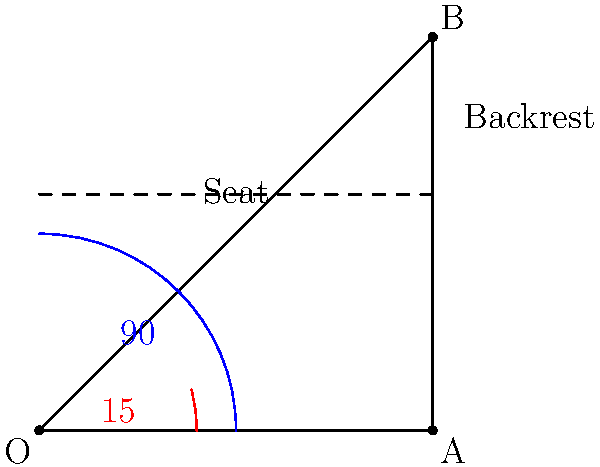As a chess historian, you're researching the optimal seating arrangements for players during famous matches. What is the recommended angle between the seat and backrest of a chess player's chair based on ergonomic principles? To determine the optimal angle for a chess player's chair, we need to consider ergonomic principles that promote comfort and reduce strain during long periods of sitting. The process to arrive at the answer is as follows:

1. Ergonomic studies have shown that the ideal sitting posture maintains the natural S-curve of the spine.

2. This posture is best achieved when the angle between the seat and the backrest is slightly greater than 90 degrees.

3. The recommended range for this angle is typically between 100 to 110 degrees.

4. Within this range, 105 degrees is often cited as the optimal angle, as it provides a balance between support and comfort.

5. This angle allows for:
   a) Reduced pressure on the intervertebral discs
   b) Decreased muscle activity in the back
   c) Improved blood flow to the lower extremities

6. For chess players, who often sit for extended periods during matches, this angle helps maintain alertness and reduces fatigue.

7. The 105-degree angle is represented in the diagram as the complement of the 15-degree angle shown in red (90° + 15° = 105°).

Therefore, based on ergonomic principles, the recommended angle between the seat and backrest of a chess player's chair is 105 degrees.
Answer: 105 degrees 